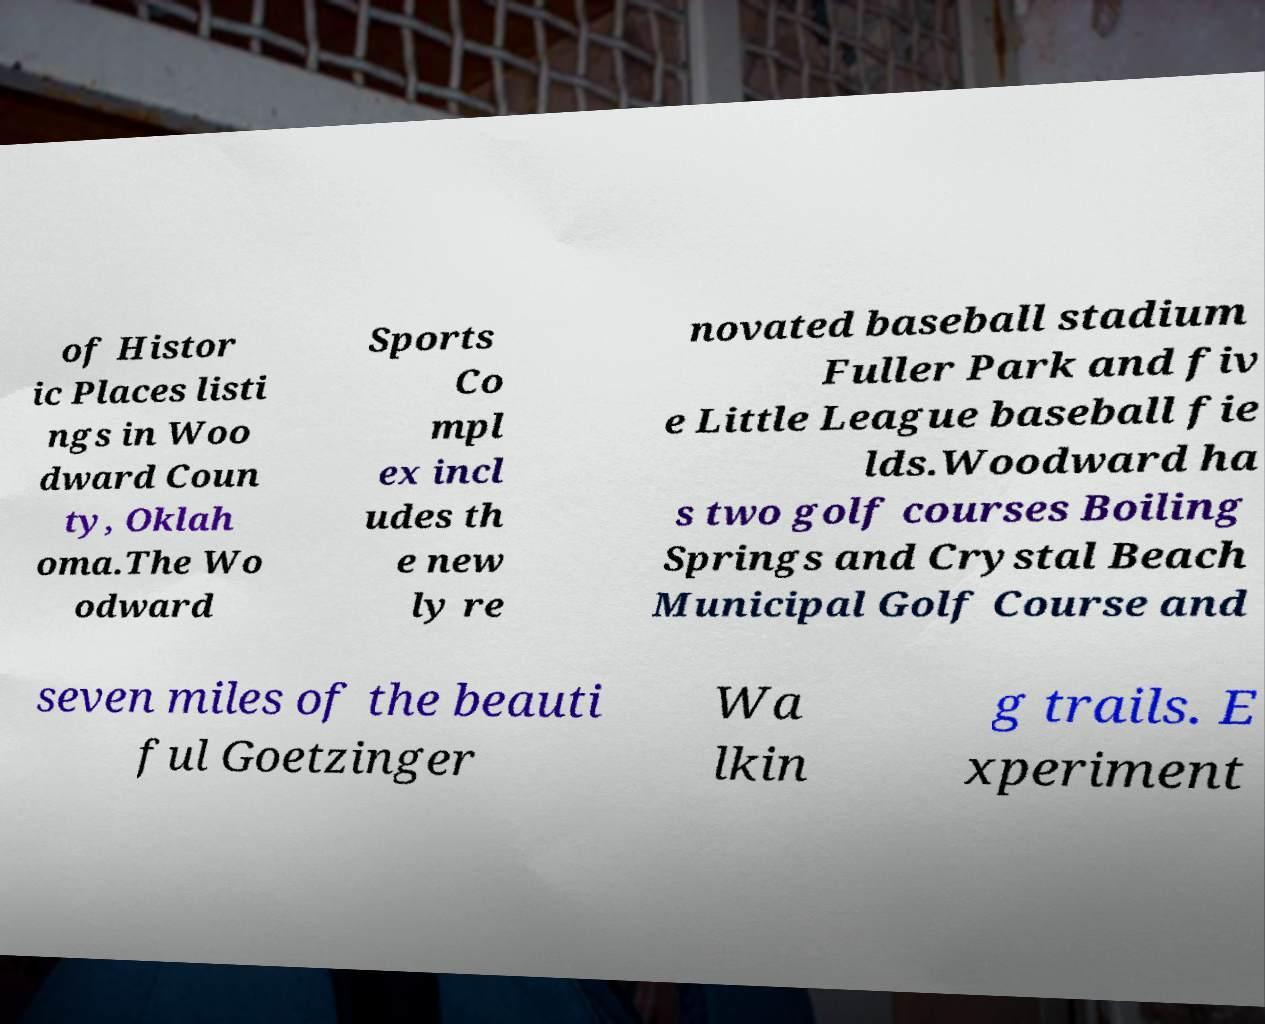For documentation purposes, I need the text within this image transcribed. Could you provide that? of Histor ic Places listi ngs in Woo dward Coun ty, Oklah oma.The Wo odward Sports Co mpl ex incl udes th e new ly re novated baseball stadium Fuller Park and fiv e Little League baseball fie lds.Woodward ha s two golf courses Boiling Springs and Crystal Beach Municipal Golf Course and seven miles of the beauti ful Goetzinger Wa lkin g trails. E xperiment 